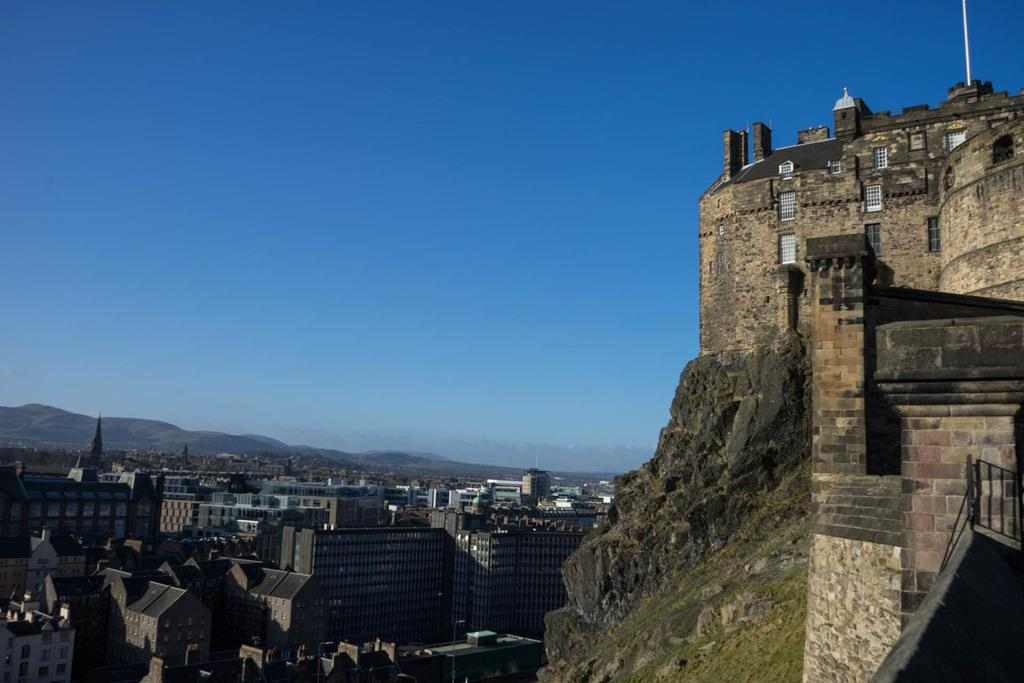What is located on the hill in the right side of the image? There is a monument on a hill in the right of the image. What can be seen in the left side of the image? There are many buildings and towers in the left of the image. What type of natural feature is present in the left side of the image? There are hills in the left of the image. What is visible at the top of the image? The sky is visible at the top of the image. What type of birds can be heard singing in the image? There are no birds present in the image, so it is not possible to hear them singing. What change in the weather can be observed in the image? The image does not provide any information about the weather, so it is not possible to observe any changes in the weather. 